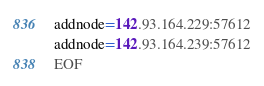<code> <loc_0><loc_0><loc_500><loc_500><_Bash_>addnode=142.93.164.229:57612
addnode=142.93.164.239:57612
EOF</code> 